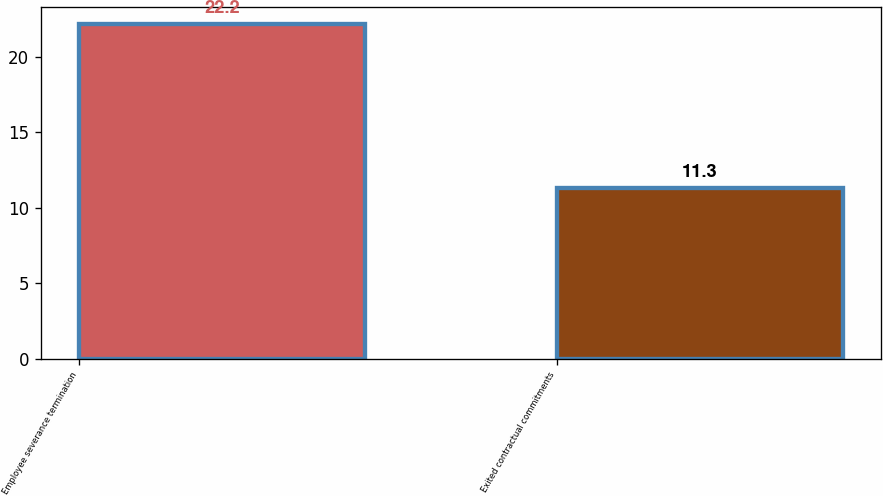Convert chart to OTSL. <chart><loc_0><loc_0><loc_500><loc_500><bar_chart><fcel>Employee severance termination<fcel>Exited contractual commitments<nl><fcel>22.2<fcel>11.3<nl></chart> 